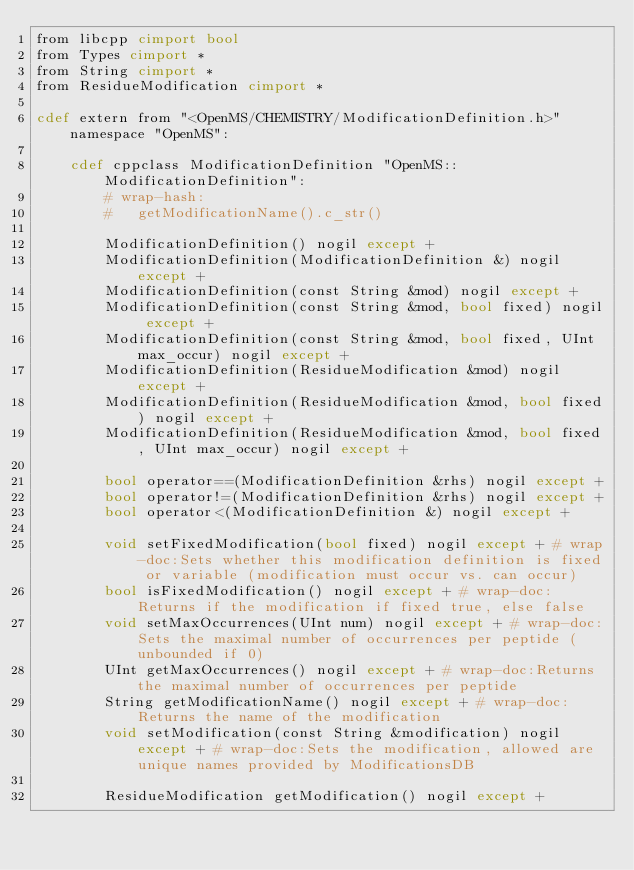<code> <loc_0><loc_0><loc_500><loc_500><_Cython_>from libcpp cimport bool
from Types cimport *
from String cimport *
from ResidueModification cimport *

cdef extern from "<OpenMS/CHEMISTRY/ModificationDefinition.h>" namespace "OpenMS":
    
    cdef cppclass ModificationDefinition "OpenMS::ModificationDefinition":
        # wrap-hash:
        #   getModificationName().c_str()

        ModificationDefinition() nogil except +
        ModificationDefinition(ModificationDefinition &) nogil except +
        ModificationDefinition(const String &mod) nogil except +
        ModificationDefinition(const String &mod, bool fixed) nogil except +
        ModificationDefinition(const String &mod, bool fixed, UInt max_occur) nogil except +
        ModificationDefinition(ResidueModification &mod) nogil except +
        ModificationDefinition(ResidueModification &mod, bool fixed) nogil except +
        ModificationDefinition(ResidueModification &mod, bool fixed, UInt max_occur) nogil except +

        bool operator==(ModificationDefinition &rhs) nogil except +
        bool operator!=(ModificationDefinition &rhs) nogil except +
        bool operator<(ModificationDefinition &) nogil except +

        void setFixedModification(bool fixed) nogil except + # wrap-doc:Sets whether this modification definition is fixed or variable (modification must occur vs. can occur)
        bool isFixedModification() nogil except + # wrap-doc:Returns if the modification if fixed true, else false
        void setMaxOccurrences(UInt num) nogil except + # wrap-doc:Sets the maximal number of occurrences per peptide (unbounded if 0)
        UInt getMaxOccurrences() nogil except + # wrap-doc:Returns the maximal number of occurrences per peptide
        String getModificationName() nogil except + # wrap-doc:Returns the name of the modification
        void setModification(const String &modification) nogil except + # wrap-doc:Sets the modification, allowed are unique names provided by ModificationsDB

        ResidueModification getModification() nogil except +

</code> 